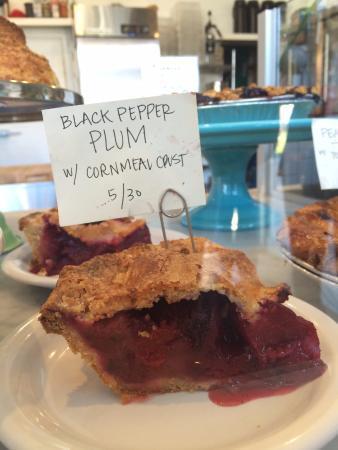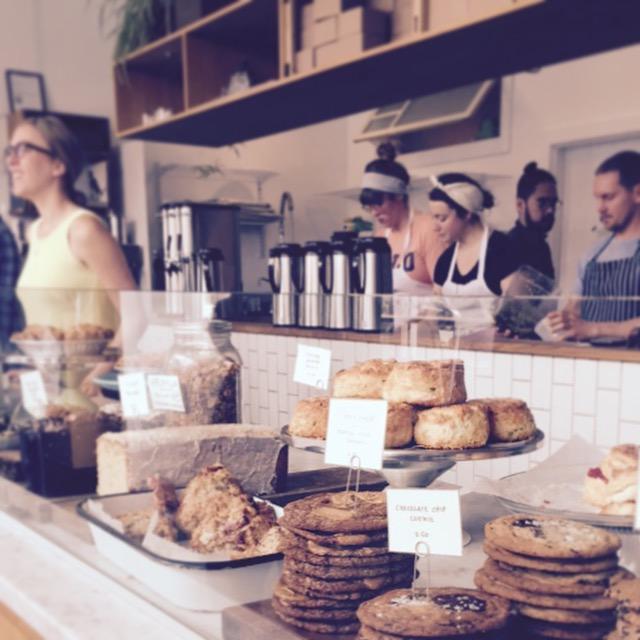The first image is the image on the left, the second image is the image on the right. Analyze the images presented: Is the assertion "Each image contains a person behind a counter." valid? Answer yes or no. No. The first image is the image on the left, the second image is the image on the right. Examine the images to the left and right. Is the description "There is a single green cake holder that contains  at least seven yellow and brown looking muffin tops." accurate? Answer yes or no. No. 